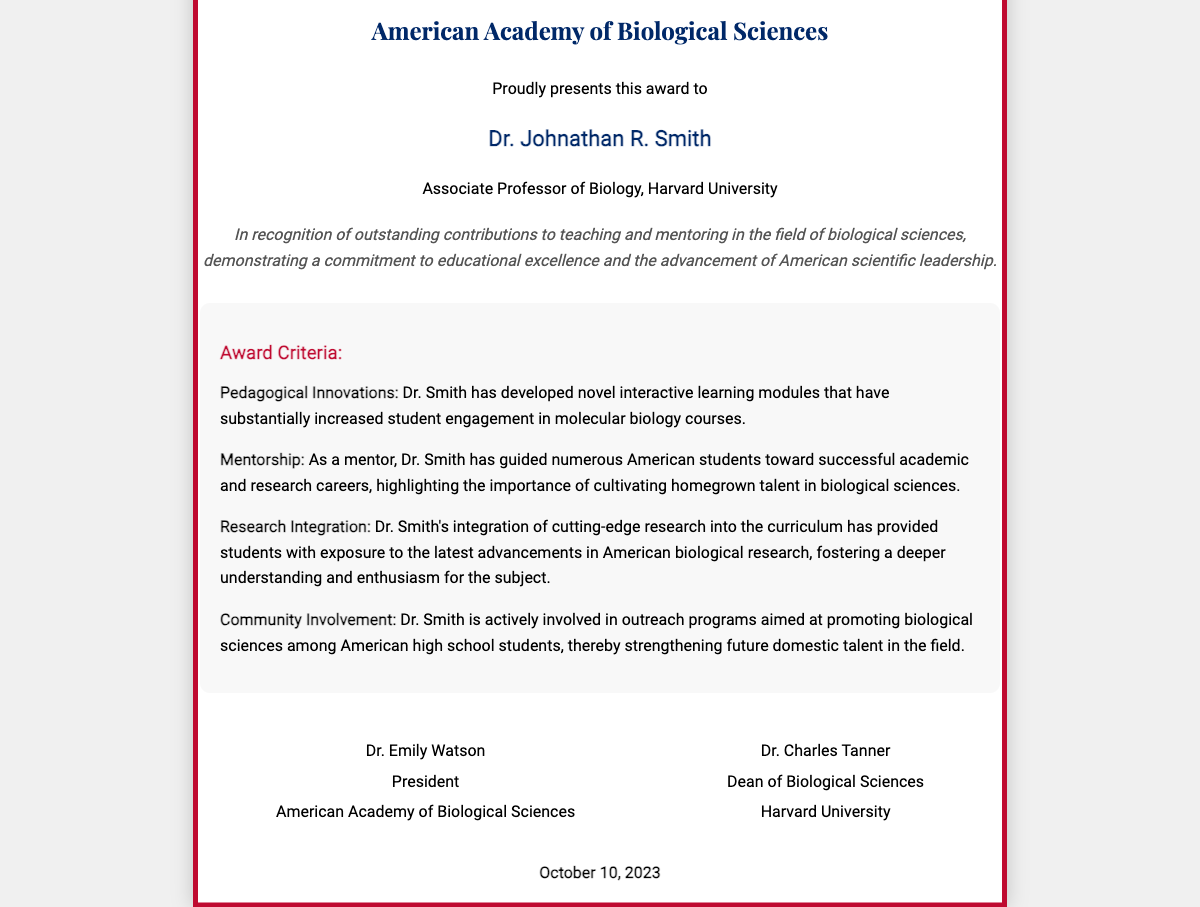What is the name of the award? The name of the award is presented in the title of the diploma, which is "Teaching Excellence Award for American Scholars in Biological Sciences."
Answer: Teaching Excellence Award for American Scholars in Biological Sciences Who is the recipient of the award? The recipient's name is stated as the individual the award is presented to.
Answer: Dr. Johnathan R. Smith What is Dr. Smith's position? Dr. Smith's position is specified in the description as an academic titleholder.
Answer: Associate Professor of Biology Which institution is Dr. Smith affiliated with? The institution is mentioned right below Dr. Smith's position, which indicates where he works.
Answer: Harvard University What is the date of the award presentation? The date is clearly stated at the bottom of the diploma, identifying when the award was issued.
Answer: October 10, 2023 What is one criterion for the award related to mentorship? One criterion about mentorship is included in the criteria section of the diploma, showcasing its significance.
Answer: Guided numerous American students What aspect of teaching does Dr. Smith excel in according to the award description? The award description outlines the area of excellence that the recipient demonstrates in teaching.
Answer: Outstanding contributions to teaching Who is the president of the American Academy of Biological Sciences? The president's name is indicated among the signatories at the bottom of the diploma.
Answer: Dr. Emily Watson What kind of outreach programs is Dr. Smith involved in? The type of outreach program is specified, demonstrating his commitment to education.
Answer: Promoting biological sciences among American high school students 